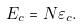Convert formula to latex. <formula><loc_0><loc_0><loc_500><loc_500>E _ { c } = N \varepsilon _ { c } .</formula> 